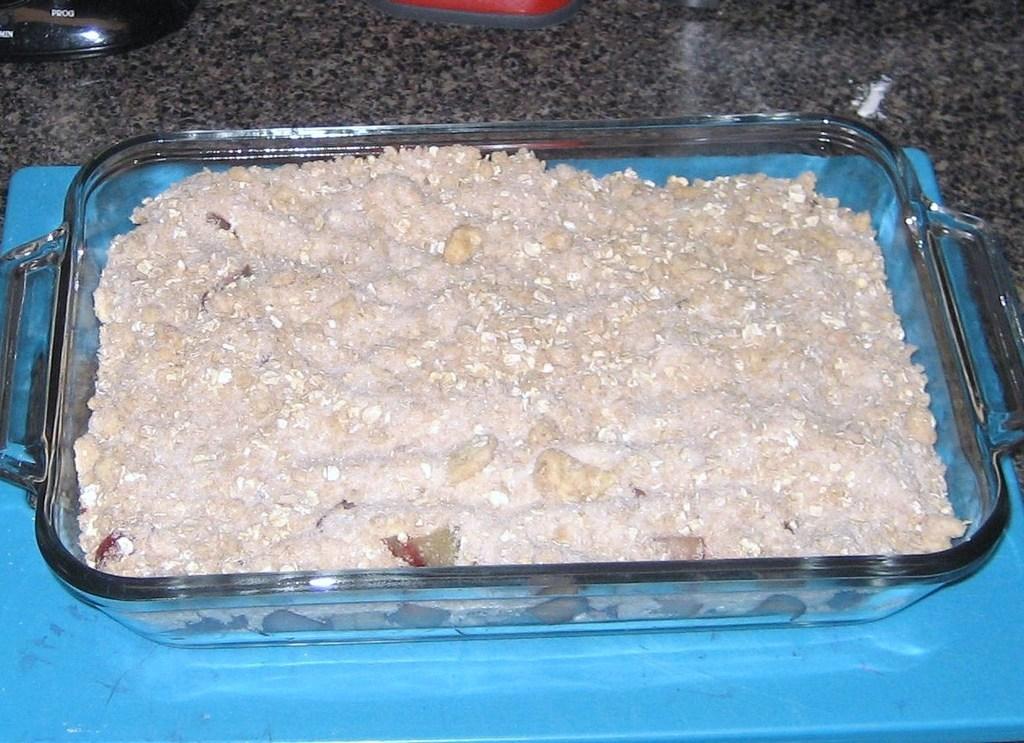Could you give a brief overview of what you see in this image? In this image we can see some food items on the tray, which is on the blue colored surface, there are some other objects on the kitchen slab. 